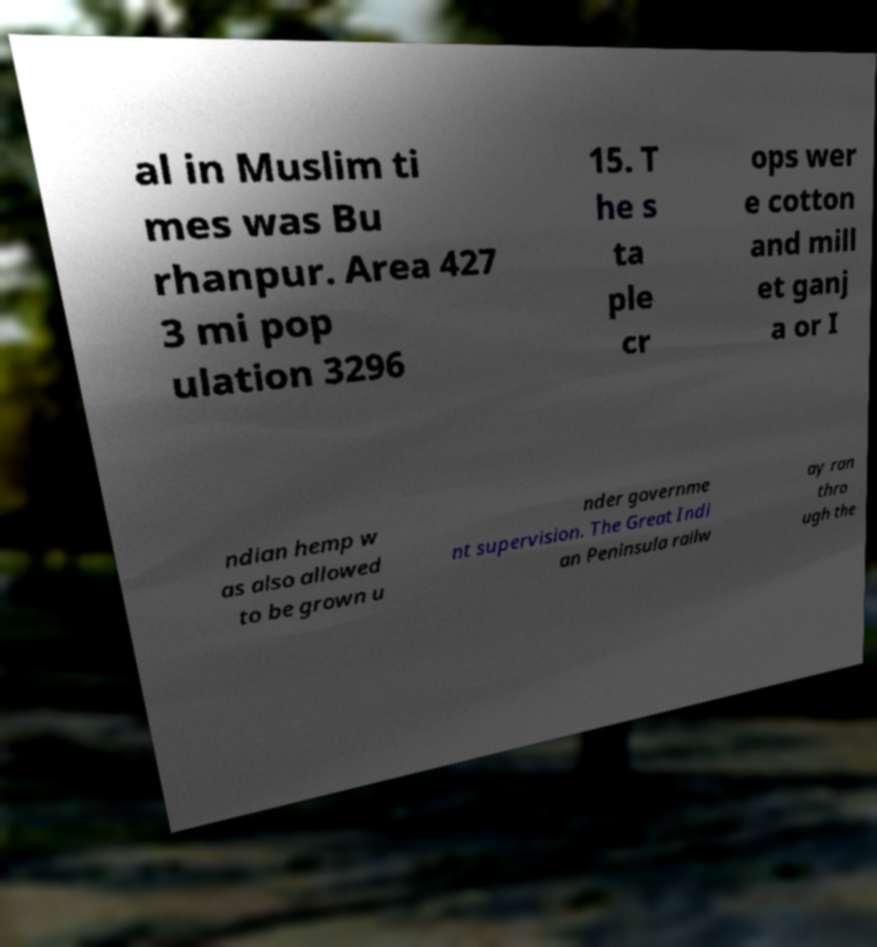For documentation purposes, I need the text within this image transcribed. Could you provide that? al in Muslim ti mes was Bu rhanpur. Area 427 3 mi pop ulation 3296 15. T he s ta ple cr ops wer e cotton and mill et ganj a or I ndian hemp w as also allowed to be grown u nder governme nt supervision. The Great Indi an Peninsula railw ay ran thro ugh the 